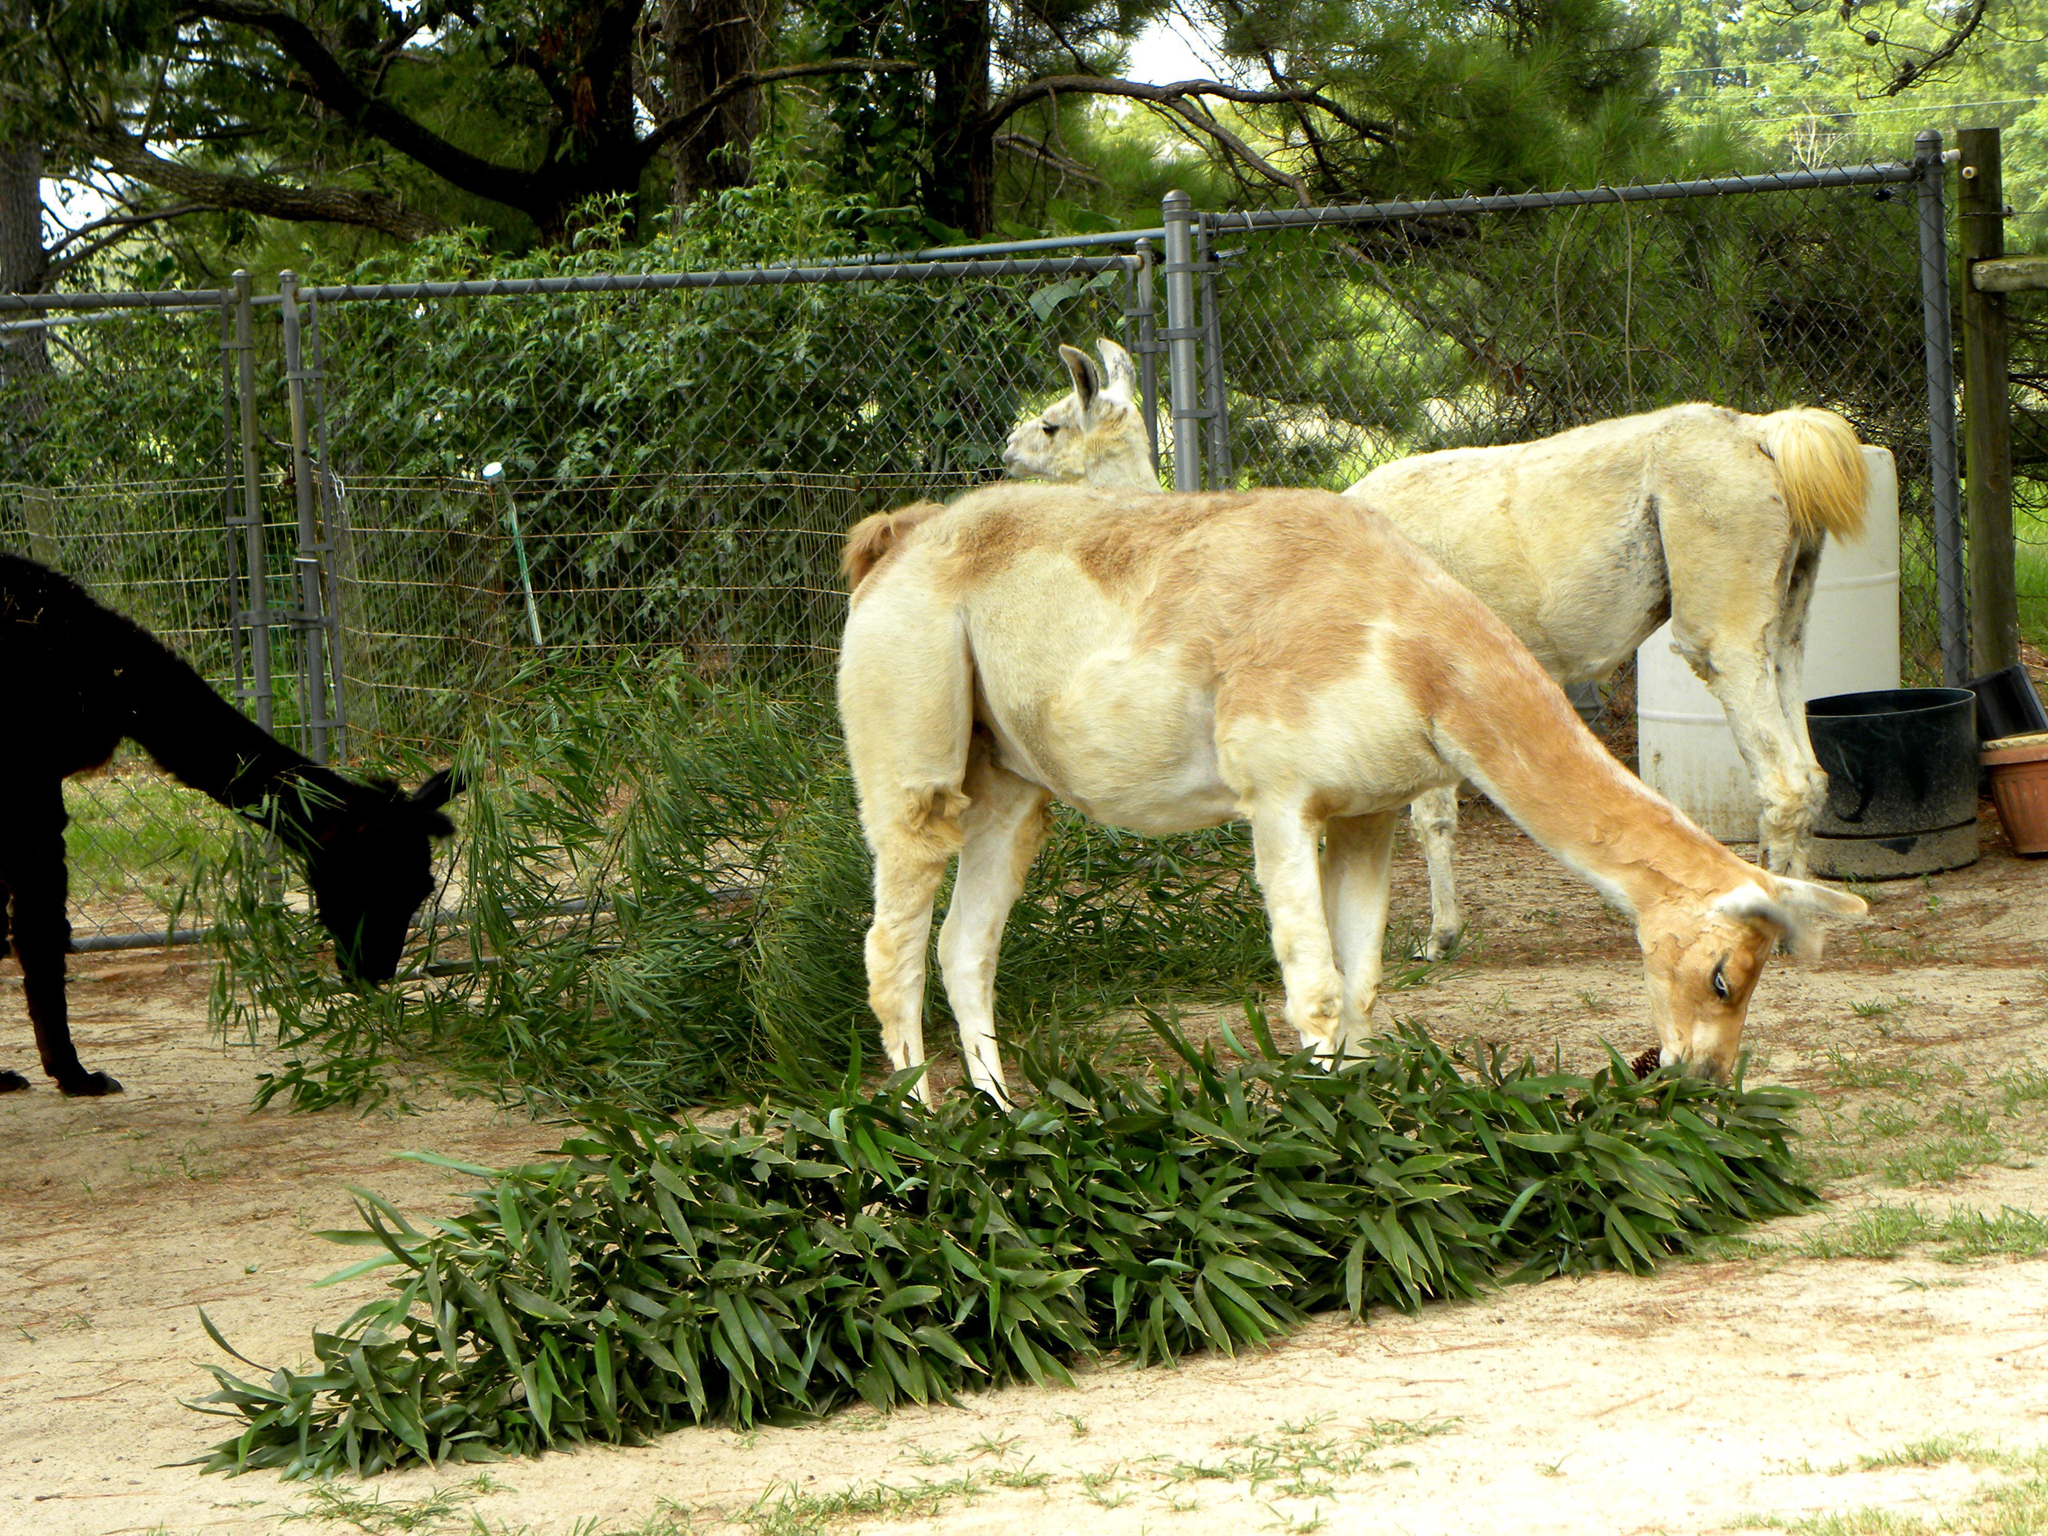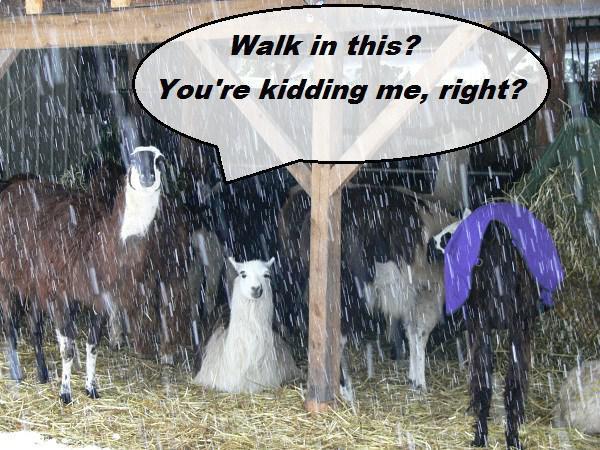The first image is the image on the left, the second image is the image on the right. For the images displayed, is the sentence "A human is feeding one of the llamas" factually correct? Answer yes or no. No. The first image is the image on the left, the second image is the image on the right. Examine the images to the left and right. Is the description "In at least one image there is a long necked animal facing forward left with greenery in its mouth." accurate? Answer yes or no. No. 